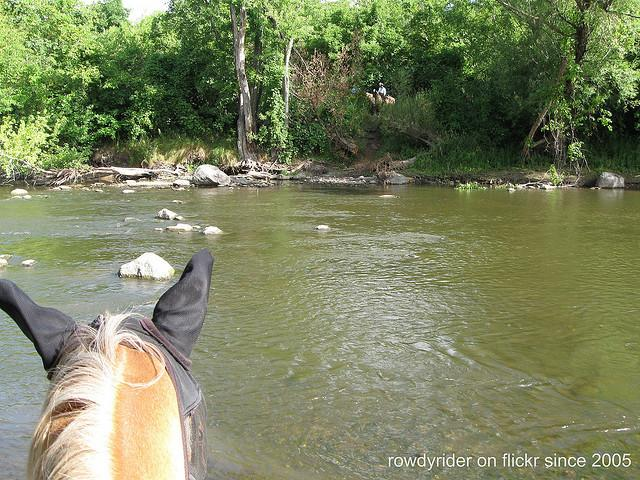What is the maximum speed of this type of animal in miles per hour? Please explain your reasoning. 55. The horse can run at 55 miles an hour. 